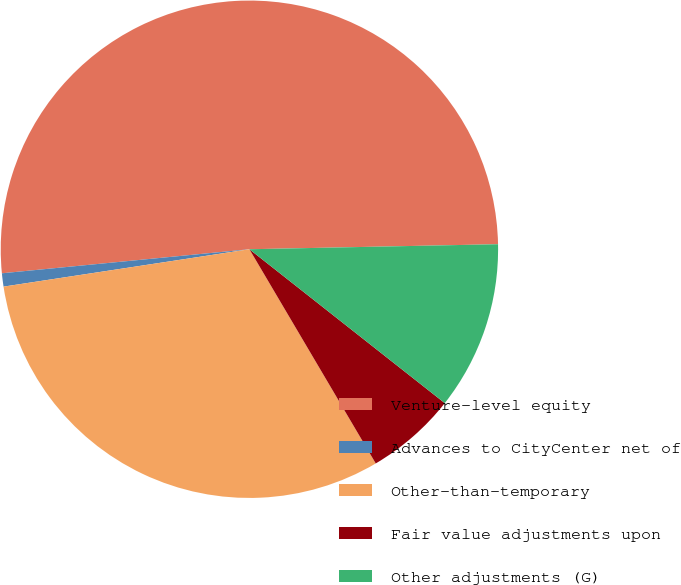Convert chart to OTSL. <chart><loc_0><loc_0><loc_500><loc_500><pie_chart><fcel>Venture-level equity<fcel>Advances to CityCenter net of<fcel>Other-than-temporary<fcel>Fair value adjustments upon<fcel>Other adjustments (G)<nl><fcel>51.22%<fcel>0.86%<fcel>31.08%<fcel>5.9%<fcel>10.94%<nl></chart> 